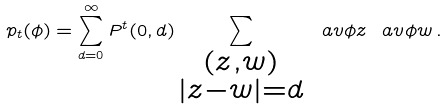Convert formula to latex. <formula><loc_0><loc_0><loc_500><loc_500>p _ { t } ( \phi ) = \sum _ { d = 0 } ^ { \infty } P ^ { t } ( 0 , d ) \sum _ { \substack { ( z , w ) \\ | z - w | = d } } \ a v { \phi } { z } \ a v { \phi } { w } \, .</formula> 